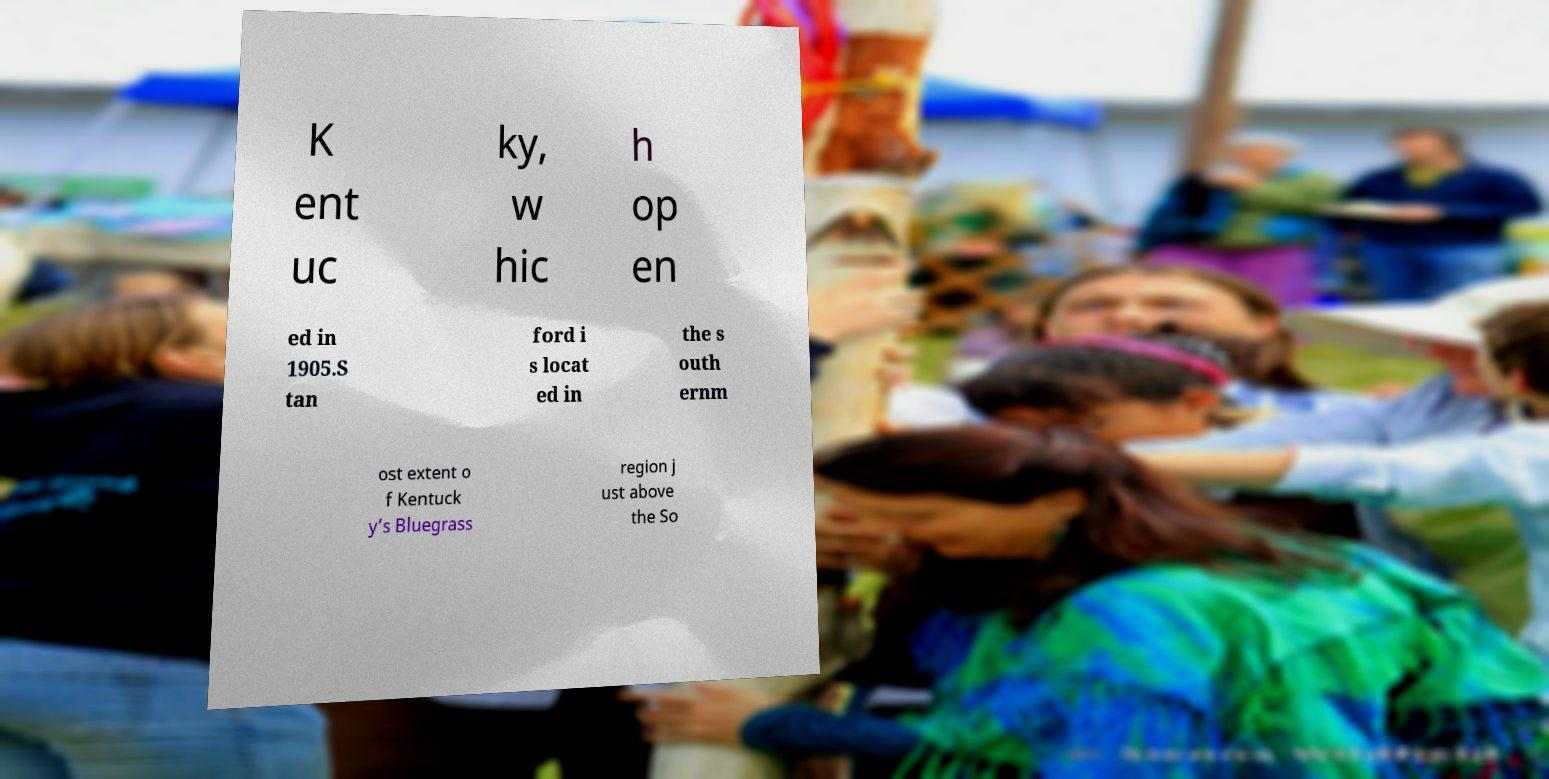Can you read and provide the text displayed in the image?This photo seems to have some interesting text. Can you extract and type it out for me? K ent uc ky, w hic h op en ed in 1905.S tan ford i s locat ed in the s outh ernm ost extent o f Kentuck y’s Bluegrass region j ust above the So 